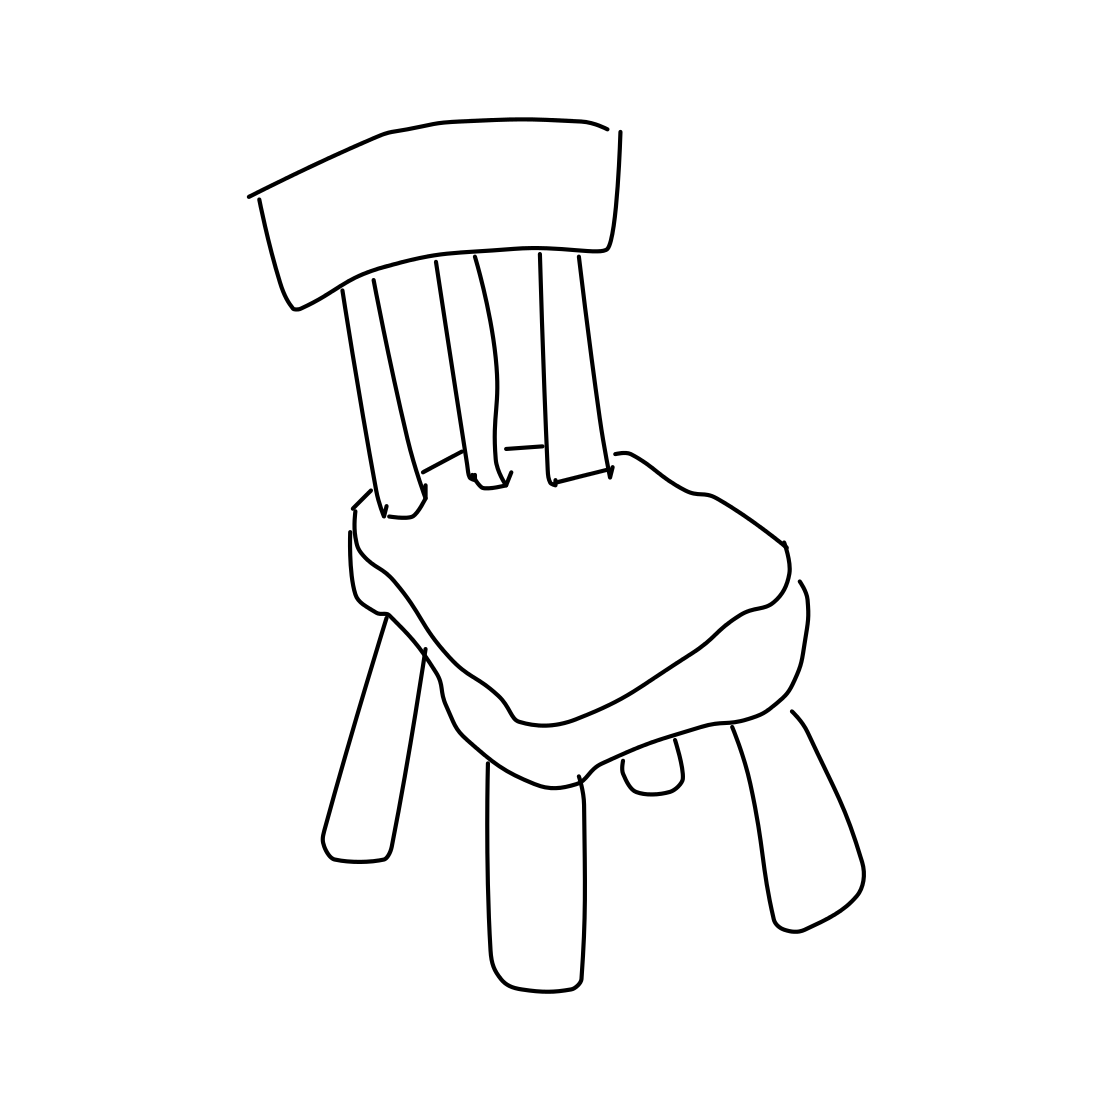Describe the style or design of the chair in this image. The chair in the image appears to be depicted in a minimalist style, primarily focusing on essential shapes and lines without detailed textures or patterns. It features a typical four-legged design, with a slightly backwards-leaning backrest and a plain, cushion-shaped seat. 